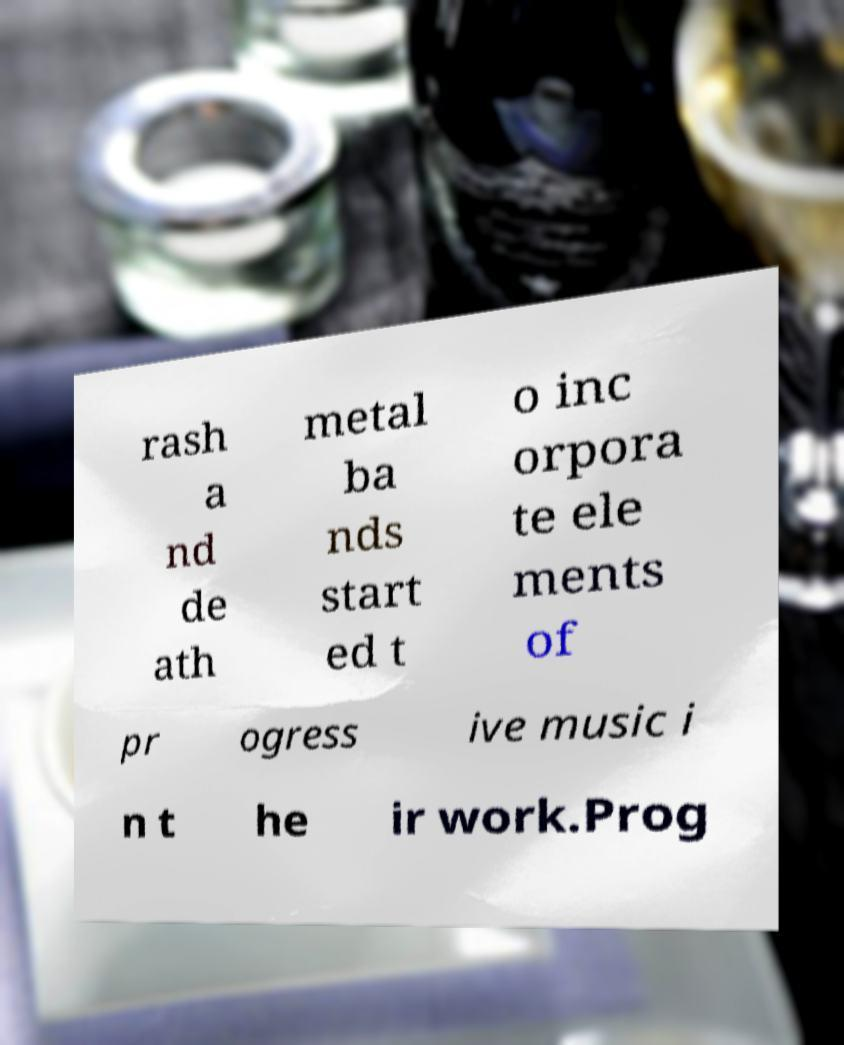Can you accurately transcribe the text from the provided image for me? rash a nd de ath metal ba nds start ed t o inc orpora te ele ments of pr ogress ive music i n t he ir work.Prog 